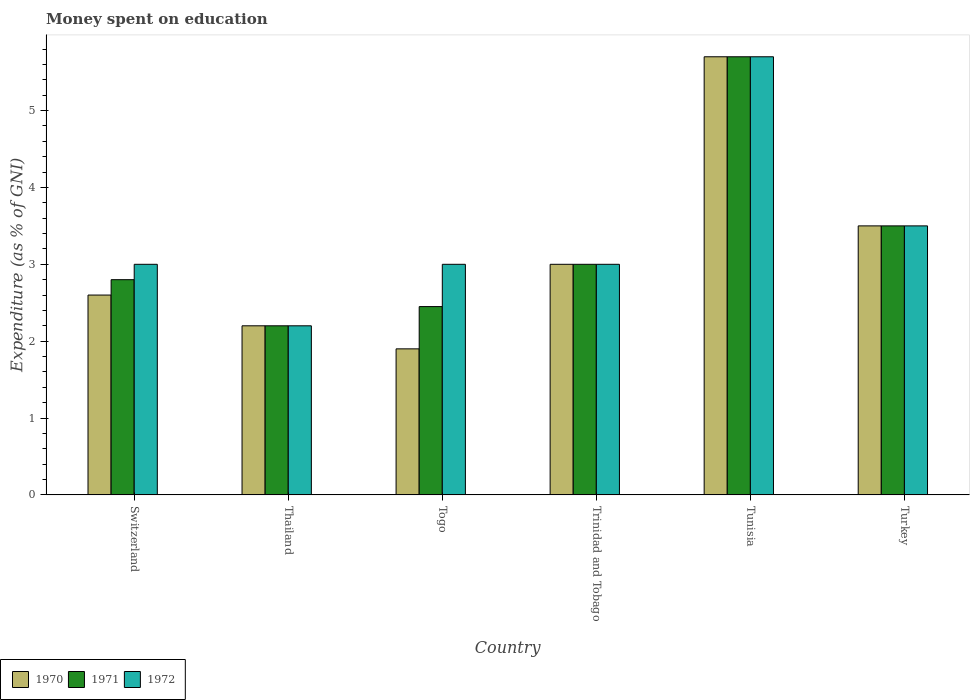How many bars are there on the 5th tick from the right?
Your answer should be very brief. 3. What is the label of the 1st group of bars from the left?
Your answer should be compact. Switzerland. What is the amount of money spent on education in 1970 in Tunisia?
Provide a short and direct response. 5.7. In which country was the amount of money spent on education in 1972 maximum?
Give a very brief answer. Tunisia. In which country was the amount of money spent on education in 1970 minimum?
Provide a succinct answer. Togo. What is the total amount of money spent on education in 1970 in the graph?
Offer a very short reply. 18.9. What is the difference between the amount of money spent on education in 1970 in Thailand and that in Togo?
Offer a terse response. 0.3. What is the difference between the amount of money spent on education in 1972 in Thailand and the amount of money spent on education in 1971 in Tunisia?
Offer a terse response. -3.5. What is the average amount of money spent on education in 1971 per country?
Your answer should be compact. 3.27. In how many countries, is the amount of money spent on education in 1971 greater than 4.6 %?
Your answer should be very brief. 1. What is the ratio of the amount of money spent on education in 1970 in Togo to that in Trinidad and Tobago?
Offer a very short reply. 0.63. Is the difference between the amount of money spent on education in 1971 in Thailand and Trinidad and Tobago greater than the difference between the amount of money spent on education in 1970 in Thailand and Trinidad and Tobago?
Offer a very short reply. No. What is the difference between the highest and the lowest amount of money spent on education in 1970?
Provide a succinct answer. 3.8. In how many countries, is the amount of money spent on education in 1972 greater than the average amount of money spent on education in 1972 taken over all countries?
Your answer should be very brief. 2. What does the 1st bar from the right in Switzerland represents?
Provide a succinct answer. 1972. Where does the legend appear in the graph?
Provide a short and direct response. Bottom left. How many legend labels are there?
Provide a succinct answer. 3. What is the title of the graph?
Make the answer very short. Money spent on education. What is the label or title of the Y-axis?
Your answer should be compact. Expenditure (as % of GNI). What is the Expenditure (as % of GNI) in 1970 in Switzerland?
Your answer should be very brief. 2.6. What is the Expenditure (as % of GNI) of 1970 in Togo?
Offer a very short reply. 1.9. What is the Expenditure (as % of GNI) of 1971 in Togo?
Give a very brief answer. 2.45. What is the Expenditure (as % of GNI) in 1972 in Togo?
Provide a succinct answer. 3. What is the Expenditure (as % of GNI) in 1970 in Trinidad and Tobago?
Your answer should be compact. 3. What is the Expenditure (as % of GNI) in 1971 in Trinidad and Tobago?
Keep it short and to the point. 3. What is the Expenditure (as % of GNI) of 1972 in Trinidad and Tobago?
Provide a short and direct response. 3. What is the Expenditure (as % of GNI) of 1971 in Tunisia?
Ensure brevity in your answer.  5.7. What is the Expenditure (as % of GNI) of 1972 in Tunisia?
Provide a short and direct response. 5.7. What is the Expenditure (as % of GNI) of 1971 in Turkey?
Ensure brevity in your answer.  3.5. What is the Expenditure (as % of GNI) in 1972 in Turkey?
Provide a succinct answer. 3.5. Across all countries, what is the maximum Expenditure (as % of GNI) in 1970?
Ensure brevity in your answer.  5.7. Across all countries, what is the minimum Expenditure (as % of GNI) in 1971?
Your answer should be compact. 2.2. What is the total Expenditure (as % of GNI) of 1970 in the graph?
Your response must be concise. 18.9. What is the total Expenditure (as % of GNI) in 1971 in the graph?
Offer a terse response. 19.65. What is the total Expenditure (as % of GNI) of 1972 in the graph?
Ensure brevity in your answer.  20.4. What is the difference between the Expenditure (as % of GNI) of 1970 in Switzerland and that in Thailand?
Provide a short and direct response. 0.4. What is the difference between the Expenditure (as % of GNI) in 1972 in Switzerland and that in Thailand?
Provide a succinct answer. 0.8. What is the difference between the Expenditure (as % of GNI) in 1970 in Switzerland and that in Togo?
Give a very brief answer. 0.7. What is the difference between the Expenditure (as % of GNI) in 1971 in Switzerland and that in Trinidad and Tobago?
Give a very brief answer. -0.2. What is the difference between the Expenditure (as % of GNI) of 1972 in Switzerland and that in Trinidad and Tobago?
Your response must be concise. 0. What is the difference between the Expenditure (as % of GNI) of 1971 in Switzerland and that in Tunisia?
Provide a short and direct response. -2.9. What is the difference between the Expenditure (as % of GNI) of 1970 in Switzerland and that in Turkey?
Offer a terse response. -0.9. What is the difference between the Expenditure (as % of GNI) of 1972 in Switzerland and that in Turkey?
Your answer should be compact. -0.5. What is the difference between the Expenditure (as % of GNI) of 1970 in Thailand and that in Togo?
Offer a very short reply. 0.3. What is the difference between the Expenditure (as % of GNI) of 1971 in Thailand and that in Togo?
Your answer should be very brief. -0.25. What is the difference between the Expenditure (as % of GNI) in 1970 in Thailand and that in Trinidad and Tobago?
Make the answer very short. -0.8. What is the difference between the Expenditure (as % of GNI) in 1972 in Thailand and that in Trinidad and Tobago?
Offer a very short reply. -0.8. What is the difference between the Expenditure (as % of GNI) in 1970 in Thailand and that in Tunisia?
Provide a short and direct response. -3.5. What is the difference between the Expenditure (as % of GNI) in 1972 in Thailand and that in Tunisia?
Your answer should be compact. -3.5. What is the difference between the Expenditure (as % of GNI) in 1970 in Thailand and that in Turkey?
Offer a terse response. -1.3. What is the difference between the Expenditure (as % of GNI) in 1971 in Thailand and that in Turkey?
Provide a short and direct response. -1.3. What is the difference between the Expenditure (as % of GNI) of 1970 in Togo and that in Trinidad and Tobago?
Give a very brief answer. -1.1. What is the difference between the Expenditure (as % of GNI) in 1971 in Togo and that in Trinidad and Tobago?
Offer a very short reply. -0.55. What is the difference between the Expenditure (as % of GNI) of 1971 in Togo and that in Tunisia?
Your answer should be compact. -3.25. What is the difference between the Expenditure (as % of GNI) in 1971 in Togo and that in Turkey?
Offer a terse response. -1.05. What is the difference between the Expenditure (as % of GNI) of 1970 in Trinidad and Tobago and that in Tunisia?
Your answer should be compact. -2.7. What is the difference between the Expenditure (as % of GNI) in 1971 in Trinidad and Tobago and that in Tunisia?
Your answer should be very brief. -2.7. What is the difference between the Expenditure (as % of GNI) of 1972 in Trinidad and Tobago and that in Tunisia?
Offer a very short reply. -2.7. What is the difference between the Expenditure (as % of GNI) of 1971 in Trinidad and Tobago and that in Turkey?
Make the answer very short. -0.5. What is the difference between the Expenditure (as % of GNI) of 1972 in Trinidad and Tobago and that in Turkey?
Offer a very short reply. -0.5. What is the difference between the Expenditure (as % of GNI) of 1970 in Tunisia and that in Turkey?
Your answer should be compact. 2.2. What is the difference between the Expenditure (as % of GNI) in 1971 in Tunisia and that in Turkey?
Keep it short and to the point. 2.2. What is the difference between the Expenditure (as % of GNI) of 1970 in Switzerland and the Expenditure (as % of GNI) of 1972 in Thailand?
Your response must be concise. 0.4. What is the difference between the Expenditure (as % of GNI) in 1970 in Switzerland and the Expenditure (as % of GNI) in 1972 in Togo?
Provide a succinct answer. -0.4. What is the difference between the Expenditure (as % of GNI) of 1971 in Switzerland and the Expenditure (as % of GNI) of 1972 in Togo?
Your answer should be very brief. -0.2. What is the difference between the Expenditure (as % of GNI) of 1970 in Switzerland and the Expenditure (as % of GNI) of 1971 in Trinidad and Tobago?
Keep it short and to the point. -0.4. What is the difference between the Expenditure (as % of GNI) of 1970 in Switzerland and the Expenditure (as % of GNI) of 1972 in Trinidad and Tobago?
Make the answer very short. -0.4. What is the difference between the Expenditure (as % of GNI) in 1971 in Switzerland and the Expenditure (as % of GNI) in 1972 in Trinidad and Tobago?
Give a very brief answer. -0.2. What is the difference between the Expenditure (as % of GNI) in 1970 in Switzerland and the Expenditure (as % of GNI) in 1971 in Tunisia?
Offer a terse response. -3.1. What is the difference between the Expenditure (as % of GNI) of 1971 in Switzerland and the Expenditure (as % of GNI) of 1972 in Tunisia?
Ensure brevity in your answer.  -2.9. What is the difference between the Expenditure (as % of GNI) of 1970 in Switzerland and the Expenditure (as % of GNI) of 1971 in Turkey?
Provide a short and direct response. -0.9. What is the difference between the Expenditure (as % of GNI) in 1970 in Switzerland and the Expenditure (as % of GNI) in 1972 in Turkey?
Give a very brief answer. -0.9. What is the difference between the Expenditure (as % of GNI) of 1971 in Switzerland and the Expenditure (as % of GNI) of 1972 in Turkey?
Ensure brevity in your answer.  -0.7. What is the difference between the Expenditure (as % of GNI) of 1970 in Thailand and the Expenditure (as % of GNI) of 1971 in Togo?
Keep it short and to the point. -0.25. What is the difference between the Expenditure (as % of GNI) in 1970 in Thailand and the Expenditure (as % of GNI) in 1972 in Togo?
Your answer should be compact. -0.8. What is the difference between the Expenditure (as % of GNI) in 1970 in Thailand and the Expenditure (as % of GNI) in 1971 in Tunisia?
Make the answer very short. -3.5. What is the difference between the Expenditure (as % of GNI) in 1971 in Thailand and the Expenditure (as % of GNI) in 1972 in Tunisia?
Your answer should be compact. -3.5. What is the difference between the Expenditure (as % of GNI) of 1970 in Thailand and the Expenditure (as % of GNI) of 1972 in Turkey?
Provide a short and direct response. -1.3. What is the difference between the Expenditure (as % of GNI) of 1970 in Togo and the Expenditure (as % of GNI) of 1971 in Trinidad and Tobago?
Your answer should be very brief. -1.1. What is the difference between the Expenditure (as % of GNI) of 1970 in Togo and the Expenditure (as % of GNI) of 1972 in Trinidad and Tobago?
Your answer should be compact. -1.1. What is the difference between the Expenditure (as % of GNI) in 1971 in Togo and the Expenditure (as % of GNI) in 1972 in Trinidad and Tobago?
Offer a terse response. -0.55. What is the difference between the Expenditure (as % of GNI) of 1970 in Togo and the Expenditure (as % of GNI) of 1971 in Tunisia?
Offer a terse response. -3.8. What is the difference between the Expenditure (as % of GNI) in 1970 in Togo and the Expenditure (as % of GNI) in 1972 in Tunisia?
Provide a succinct answer. -3.8. What is the difference between the Expenditure (as % of GNI) of 1971 in Togo and the Expenditure (as % of GNI) of 1972 in Tunisia?
Offer a terse response. -3.25. What is the difference between the Expenditure (as % of GNI) of 1971 in Togo and the Expenditure (as % of GNI) of 1972 in Turkey?
Provide a short and direct response. -1.05. What is the difference between the Expenditure (as % of GNI) in 1970 in Trinidad and Tobago and the Expenditure (as % of GNI) in 1971 in Tunisia?
Offer a very short reply. -2.7. What is the difference between the Expenditure (as % of GNI) in 1970 in Trinidad and Tobago and the Expenditure (as % of GNI) in 1972 in Turkey?
Ensure brevity in your answer.  -0.5. What is the difference between the Expenditure (as % of GNI) of 1971 in Tunisia and the Expenditure (as % of GNI) of 1972 in Turkey?
Your answer should be very brief. 2.2. What is the average Expenditure (as % of GNI) of 1970 per country?
Give a very brief answer. 3.15. What is the average Expenditure (as % of GNI) in 1971 per country?
Give a very brief answer. 3.27. What is the average Expenditure (as % of GNI) in 1972 per country?
Your answer should be compact. 3.4. What is the difference between the Expenditure (as % of GNI) in 1970 and Expenditure (as % of GNI) in 1971 in Switzerland?
Your answer should be very brief. -0.2. What is the difference between the Expenditure (as % of GNI) in 1970 and Expenditure (as % of GNI) in 1972 in Switzerland?
Offer a very short reply. -0.4. What is the difference between the Expenditure (as % of GNI) in 1970 and Expenditure (as % of GNI) in 1971 in Togo?
Your response must be concise. -0.55. What is the difference between the Expenditure (as % of GNI) of 1970 and Expenditure (as % of GNI) of 1972 in Togo?
Provide a short and direct response. -1.1. What is the difference between the Expenditure (as % of GNI) in 1971 and Expenditure (as % of GNI) in 1972 in Togo?
Your response must be concise. -0.55. What is the difference between the Expenditure (as % of GNI) in 1970 and Expenditure (as % of GNI) in 1972 in Trinidad and Tobago?
Your response must be concise. 0. What is the difference between the Expenditure (as % of GNI) in 1970 and Expenditure (as % of GNI) in 1971 in Tunisia?
Your answer should be compact. 0. What is the difference between the Expenditure (as % of GNI) of 1970 and Expenditure (as % of GNI) of 1972 in Tunisia?
Your answer should be very brief. 0. What is the difference between the Expenditure (as % of GNI) of 1971 and Expenditure (as % of GNI) of 1972 in Tunisia?
Offer a very short reply. 0. What is the difference between the Expenditure (as % of GNI) in 1970 and Expenditure (as % of GNI) in 1972 in Turkey?
Make the answer very short. 0. What is the ratio of the Expenditure (as % of GNI) in 1970 in Switzerland to that in Thailand?
Provide a short and direct response. 1.18. What is the ratio of the Expenditure (as % of GNI) of 1971 in Switzerland to that in Thailand?
Offer a terse response. 1.27. What is the ratio of the Expenditure (as % of GNI) of 1972 in Switzerland to that in Thailand?
Provide a succinct answer. 1.36. What is the ratio of the Expenditure (as % of GNI) of 1970 in Switzerland to that in Togo?
Keep it short and to the point. 1.37. What is the ratio of the Expenditure (as % of GNI) in 1970 in Switzerland to that in Trinidad and Tobago?
Your response must be concise. 0.87. What is the ratio of the Expenditure (as % of GNI) in 1972 in Switzerland to that in Trinidad and Tobago?
Your answer should be very brief. 1. What is the ratio of the Expenditure (as % of GNI) in 1970 in Switzerland to that in Tunisia?
Provide a succinct answer. 0.46. What is the ratio of the Expenditure (as % of GNI) in 1971 in Switzerland to that in Tunisia?
Ensure brevity in your answer.  0.49. What is the ratio of the Expenditure (as % of GNI) of 1972 in Switzerland to that in Tunisia?
Offer a very short reply. 0.53. What is the ratio of the Expenditure (as % of GNI) in 1970 in Switzerland to that in Turkey?
Offer a terse response. 0.74. What is the ratio of the Expenditure (as % of GNI) of 1971 in Switzerland to that in Turkey?
Your response must be concise. 0.8. What is the ratio of the Expenditure (as % of GNI) in 1972 in Switzerland to that in Turkey?
Give a very brief answer. 0.86. What is the ratio of the Expenditure (as % of GNI) in 1970 in Thailand to that in Togo?
Provide a succinct answer. 1.16. What is the ratio of the Expenditure (as % of GNI) of 1971 in Thailand to that in Togo?
Keep it short and to the point. 0.9. What is the ratio of the Expenditure (as % of GNI) in 1972 in Thailand to that in Togo?
Keep it short and to the point. 0.73. What is the ratio of the Expenditure (as % of GNI) in 1970 in Thailand to that in Trinidad and Tobago?
Your response must be concise. 0.73. What is the ratio of the Expenditure (as % of GNI) in 1971 in Thailand to that in Trinidad and Tobago?
Give a very brief answer. 0.73. What is the ratio of the Expenditure (as % of GNI) of 1972 in Thailand to that in Trinidad and Tobago?
Offer a terse response. 0.73. What is the ratio of the Expenditure (as % of GNI) of 1970 in Thailand to that in Tunisia?
Your answer should be compact. 0.39. What is the ratio of the Expenditure (as % of GNI) of 1971 in Thailand to that in Tunisia?
Give a very brief answer. 0.39. What is the ratio of the Expenditure (as % of GNI) of 1972 in Thailand to that in Tunisia?
Make the answer very short. 0.39. What is the ratio of the Expenditure (as % of GNI) of 1970 in Thailand to that in Turkey?
Your answer should be very brief. 0.63. What is the ratio of the Expenditure (as % of GNI) of 1971 in Thailand to that in Turkey?
Your answer should be compact. 0.63. What is the ratio of the Expenditure (as % of GNI) of 1972 in Thailand to that in Turkey?
Offer a terse response. 0.63. What is the ratio of the Expenditure (as % of GNI) in 1970 in Togo to that in Trinidad and Tobago?
Make the answer very short. 0.63. What is the ratio of the Expenditure (as % of GNI) in 1971 in Togo to that in Trinidad and Tobago?
Provide a succinct answer. 0.82. What is the ratio of the Expenditure (as % of GNI) in 1971 in Togo to that in Tunisia?
Offer a very short reply. 0.43. What is the ratio of the Expenditure (as % of GNI) in 1972 in Togo to that in Tunisia?
Give a very brief answer. 0.53. What is the ratio of the Expenditure (as % of GNI) in 1970 in Togo to that in Turkey?
Provide a short and direct response. 0.54. What is the ratio of the Expenditure (as % of GNI) in 1970 in Trinidad and Tobago to that in Tunisia?
Offer a terse response. 0.53. What is the ratio of the Expenditure (as % of GNI) of 1971 in Trinidad and Tobago to that in Tunisia?
Give a very brief answer. 0.53. What is the ratio of the Expenditure (as % of GNI) of 1972 in Trinidad and Tobago to that in Tunisia?
Your answer should be very brief. 0.53. What is the ratio of the Expenditure (as % of GNI) of 1970 in Tunisia to that in Turkey?
Provide a short and direct response. 1.63. What is the ratio of the Expenditure (as % of GNI) of 1971 in Tunisia to that in Turkey?
Make the answer very short. 1.63. What is the ratio of the Expenditure (as % of GNI) in 1972 in Tunisia to that in Turkey?
Provide a short and direct response. 1.63. What is the difference between the highest and the second highest Expenditure (as % of GNI) of 1970?
Your answer should be very brief. 2.2. What is the difference between the highest and the second highest Expenditure (as % of GNI) in 1971?
Keep it short and to the point. 2.2. What is the difference between the highest and the second highest Expenditure (as % of GNI) of 1972?
Offer a very short reply. 2.2. 